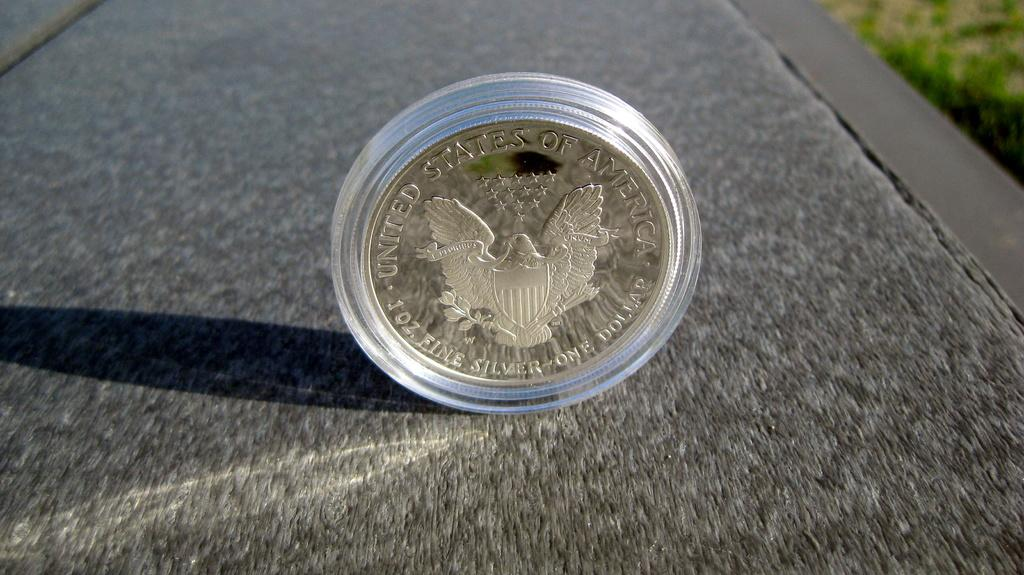<image>
Provide a brief description of the given image. A silver dollar from the United States inside a clear plastic case. 